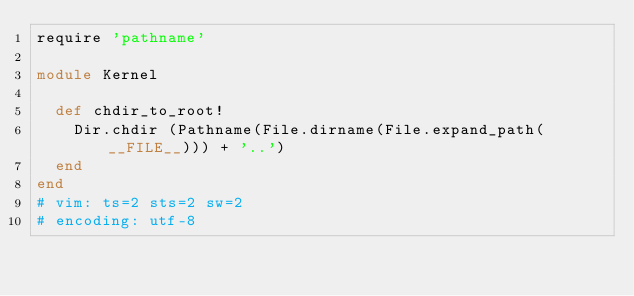<code> <loc_0><loc_0><loc_500><loc_500><_Ruby_>require 'pathname'

module Kernel

  def chdir_to_root!
    Dir.chdir (Pathname(File.dirname(File.expand_path(__FILE__))) + '..')
  end
end
# vim: ts=2 sts=2 sw=2
# encoding: utf-8
</code> 